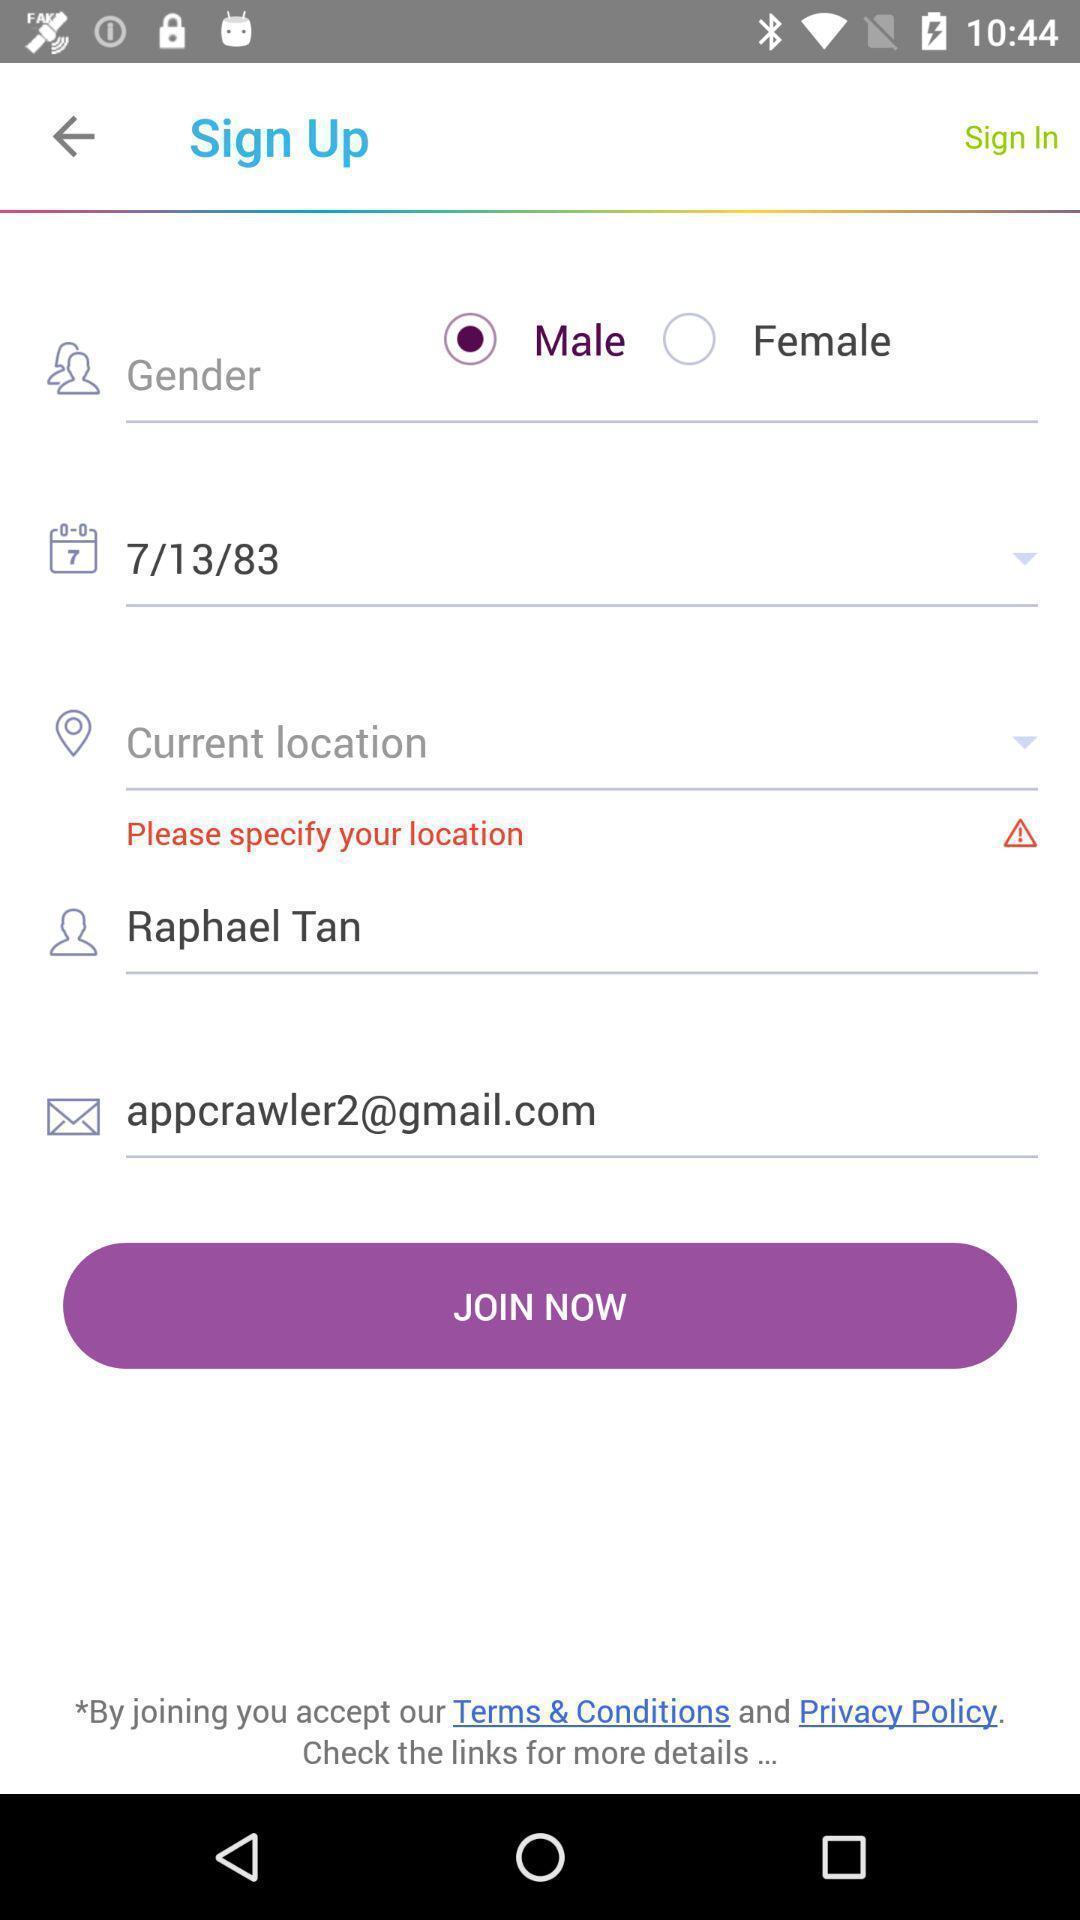Tell me about the visual elements in this screen capture. Welcome to the sign up page. 